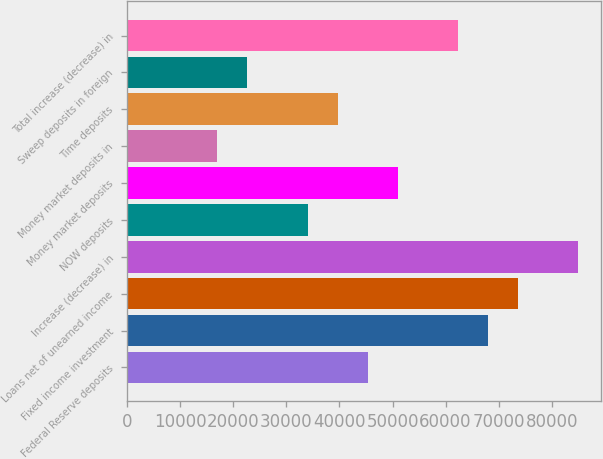Convert chart. <chart><loc_0><loc_0><loc_500><loc_500><bar_chart><fcel>Federal Reserve deposits<fcel>Fixed income investment<fcel>Loans net of unearned income<fcel>Increase (decrease) in<fcel>NOW deposits<fcel>Money market deposits<fcel>Money market deposits in<fcel>Time deposits<fcel>Sweep deposits in foreign<fcel>Total increase (decrease) in<nl><fcel>45326.6<fcel>67975.4<fcel>73637.6<fcel>84962<fcel>34002.2<fcel>50988.8<fcel>17015.6<fcel>39664.4<fcel>22677.8<fcel>62313.2<nl></chart> 